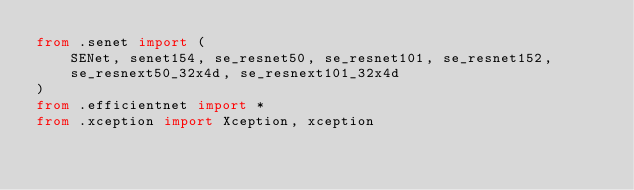<code> <loc_0><loc_0><loc_500><loc_500><_Python_>from .senet import (
    SENet, senet154, se_resnet50, se_resnet101, se_resnet152,
    se_resnext50_32x4d, se_resnext101_32x4d
)
from .efficientnet import *
from .xception import Xception, xception
</code> 